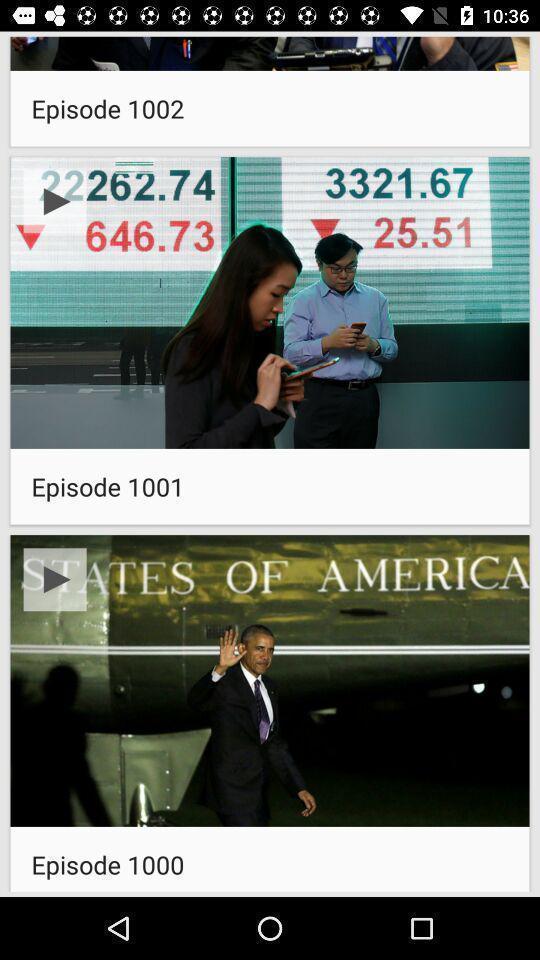Give me a summary of this screen capture. Page for the news channel app. 